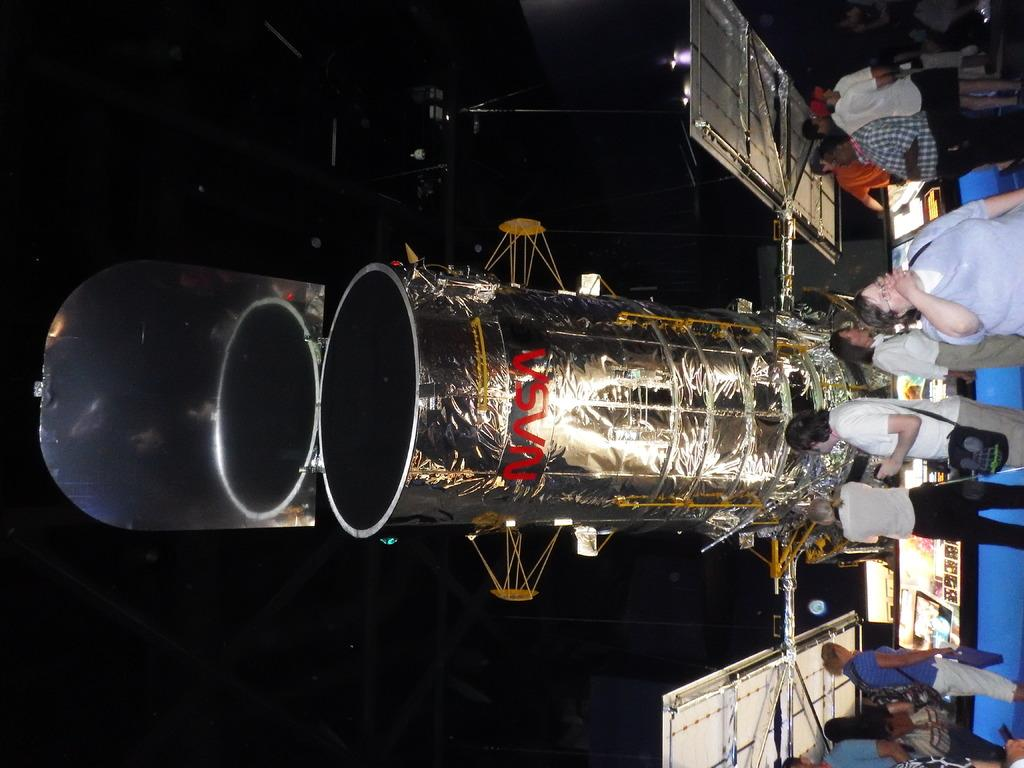Who or what can be seen in the image? There are people in the image. What is the main object in the image? There is a space telescope in the image. What type of equipment is present in the image? There are screens in the image. What is the color of the background in the image? The background of the image is dark. Can you see any feathers floating in the image? There are no feathers present in the image. Are the people in the image smiling? The provided facts do not mention the facial expressions of the people in the image, so we cannot determine if they are smiling or not. 